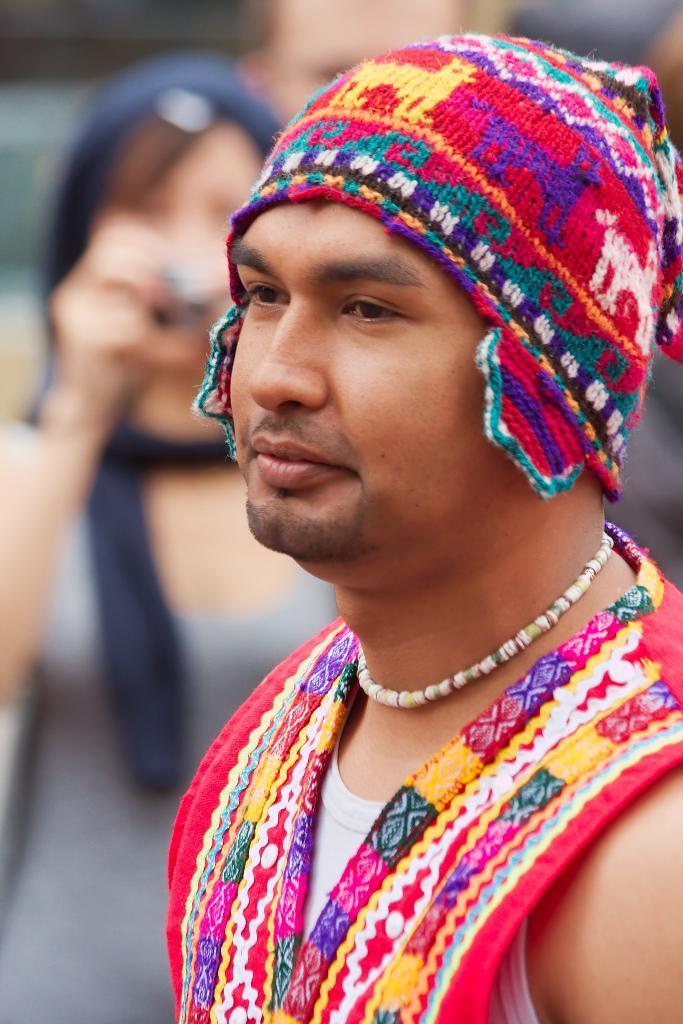How would you summarize this image in a sentence or two? This image consists of a man wearing a cap. In the background, there are many persons standing. And the background is blurred. 